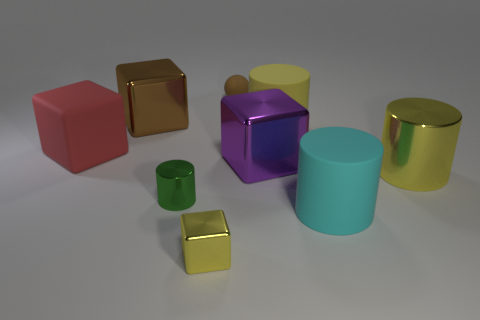What size is the shiny block that is the same color as the rubber sphere?
Provide a succinct answer. Large. Is the number of big purple cubes behind the big purple cube less than the number of large cyan cylinders that are in front of the large matte block?
Offer a terse response. Yes. What color is the tiny matte sphere?
Provide a succinct answer. Brown. Is there a metal thing that has the same color as the rubber sphere?
Provide a succinct answer. Yes. There is a large matte thing to the left of the metallic object that is behind the object that is to the left of the brown cube; what is its shape?
Offer a terse response. Cube. What is the cylinder in front of the green metal thing made of?
Offer a terse response. Rubber. How big is the cyan matte cylinder in front of the shiny block that is left of the cylinder to the left of the purple shiny cube?
Provide a succinct answer. Large. There is a green shiny cylinder; is its size the same as the yellow cylinder that is behind the red thing?
Provide a succinct answer. No. There is a big block that is behind the big yellow matte object; what color is it?
Provide a succinct answer. Brown. There is a large metallic object that is the same color as the rubber sphere; what is its shape?
Give a very brief answer. Cube. 